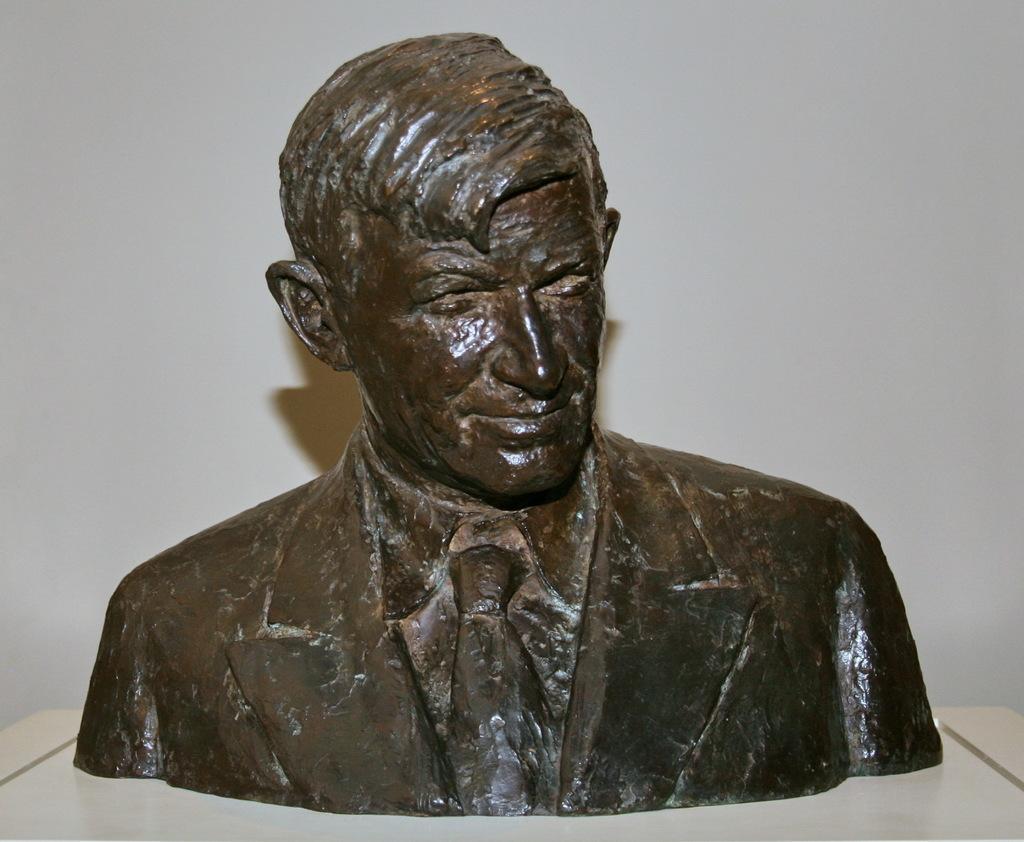Could you give a brief overview of what you see in this image? In this picture we can see a small statue of the man in the front. Behind there is a white wall. 